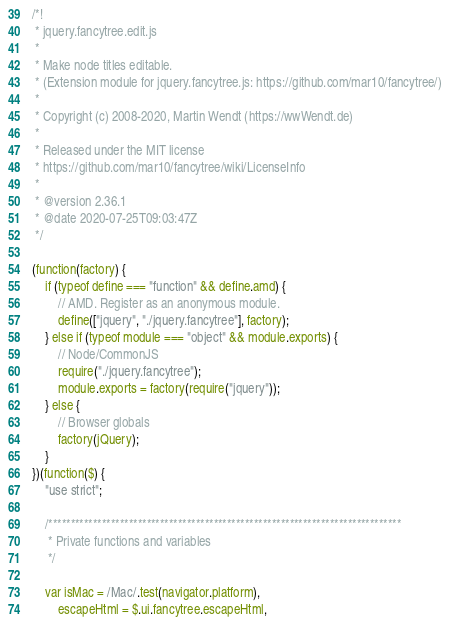Convert code to text. <code><loc_0><loc_0><loc_500><loc_500><_JavaScript_>/*!
 * jquery.fancytree.edit.js
 *
 * Make node titles editable.
 * (Extension module for jquery.fancytree.js: https://github.com/mar10/fancytree/)
 *
 * Copyright (c) 2008-2020, Martin Wendt (https://wwWendt.de)
 *
 * Released under the MIT license
 * https://github.com/mar10/fancytree/wiki/LicenseInfo
 *
 * @version 2.36.1
 * @date 2020-07-25T09:03:47Z
 */

(function(factory) {
	if (typeof define === "function" && define.amd) {
		// AMD. Register as an anonymous module.
		define(["jquery", "./jquery.fancytree"], factory);
	} else if (typeof module === "object" && module.exports) {
		// Node/CommonJS
		require("./jquery.fancytree");
		module.exports = factory(require("jquery"));
	} else {
		// Browser globals
		factory(jQuery);
	}
})(function($) {
	"use strict";

	/*******************************************************************************
	 * Private functions and variables
	 */

	var isMac = /Mac/.test(navigator.platform),
		escapeHtml = $.ui.fancytree.escapeHtml,</code> 